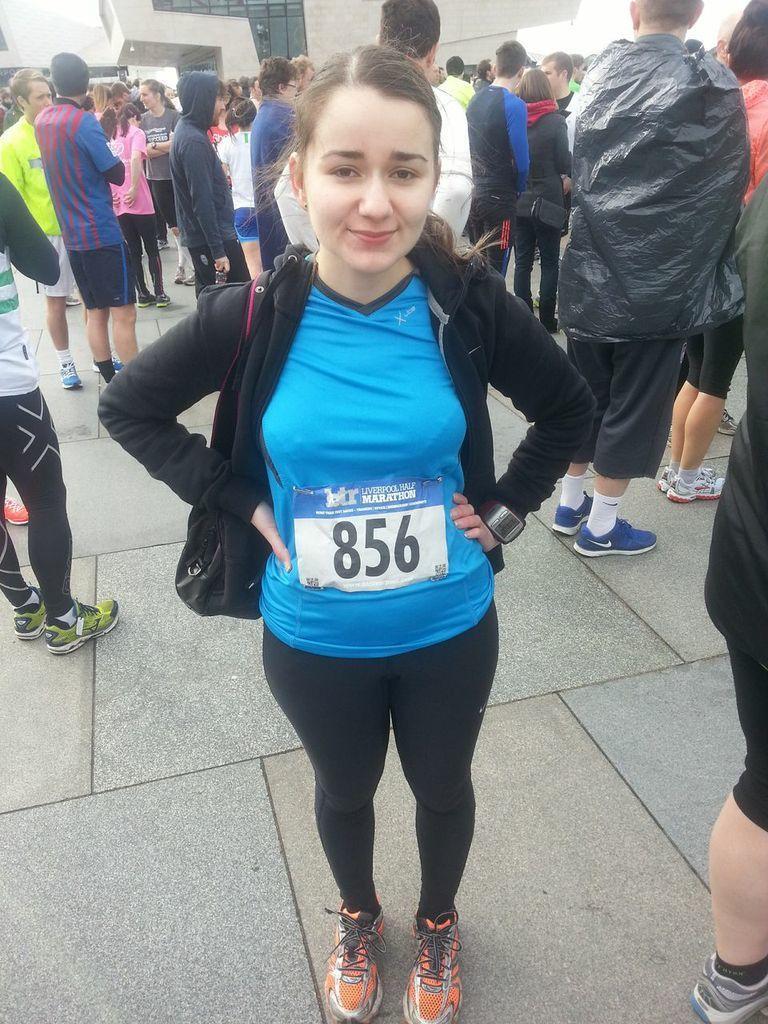Describe this image in one or two sentences. In this image I can see a woman wearing blue and black colored dress is standing on the ground. In the background I can see few other persons standing and a building. 